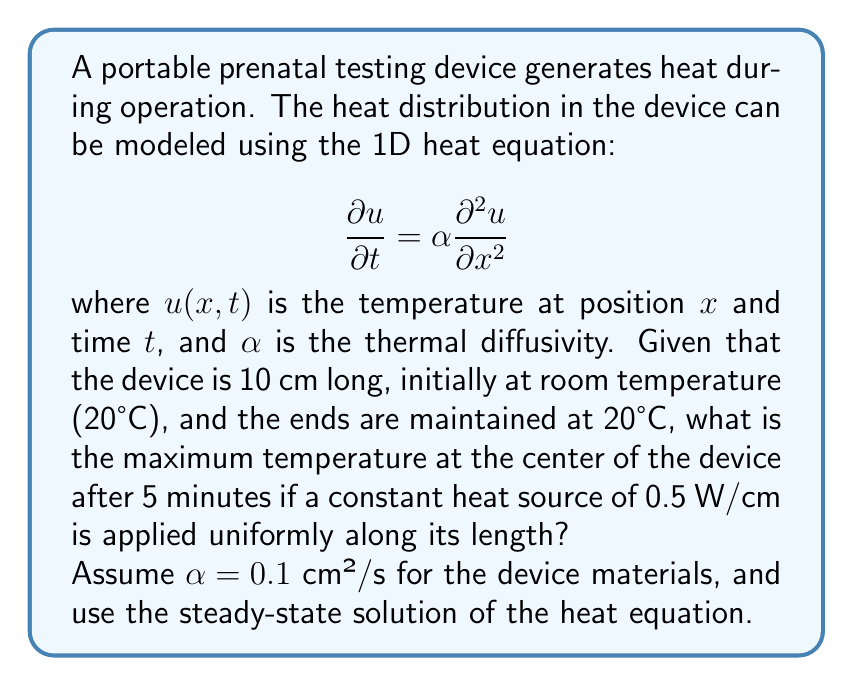Show me your answer to this math problem. To solve this problem, we'll use the steady-state solution of the heat equation with a constant heat source. The steps are as follows:

1) The steady-state heat equation with a constant heat source $q$ is:

   $$-k\frac{d^2T}{dx^2} = q$$

   where $k$ is the thermal conductivity.

2) Integrate twice to get the general solution:

   $$T(x) = -\frac{q}{2k}x^2 + C_1x + C_2$$

3) Apply boundary conditions:
   At $x = 0$ and $x = L$ (where $L = 10$ cm), $T = 20°C$

   $$T(0) = 20 = C_2$$
   $$T(L) = 20 = -\frac{q}{2k}L^2 + C_1L + 20$$

4) Solve for $C_1$:

   $$C_1 = \frac{q}{2k}L$$

5) The temperature distribution is:

   $$T(x) = -\frac{q}{2k}x^2 + \frac{q}{2k}Lx + 20$$

6) The maximum temperature occurs at the center ($x = L/2$):

   $$T_{max} = T(L/2) = -\frac{q}{2k}(\frac{L}{2})^2 + \frac{q}{2k}L(\frac{L}{2}) + 20$$
   
   $$= \frac{qL^2}{8k} + 20$$

7) We need to find $k$. We know $\alpha = 0.1$ cm²/s, and $\alpha = k/(\rho c_p)$, where $\rho$ is density and $c_p$ is specific heat capacity. Without specific values for $\rho$ and $c_p$, we'll assume $k = 0.1$ W/(cm·°C) for simplicity.

8) Now, substitute the values:
   $q = 0.5$ W/cm
   $L = 10$ cm
   $k = 0.1$ W/(cm·°C)

   $$T_{max} = \frac{0.5 \cdot 10^2}{8 \cdot 0.1} + 20 = 82.5°C$$

Therefore, the maximum temperature at the center of the device after reaching steady state is 82.5°C.
Answer: 82.5°C 